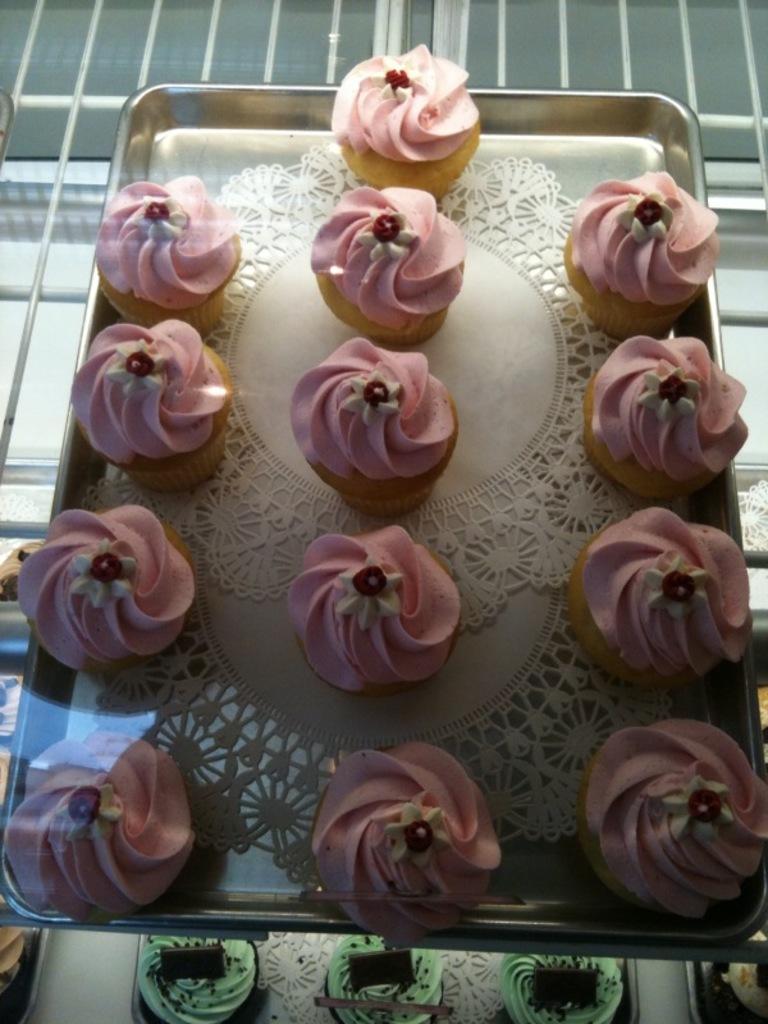Could you give a brief overview of what you see in this image? There are cupcakes, arranged on the white color cloth, which is on the steel tray, which is on the shelf. Below this, there are other cupcakes, which are arranged on other trays, which are on the other shelf. And these shelves are covered with a glass. 